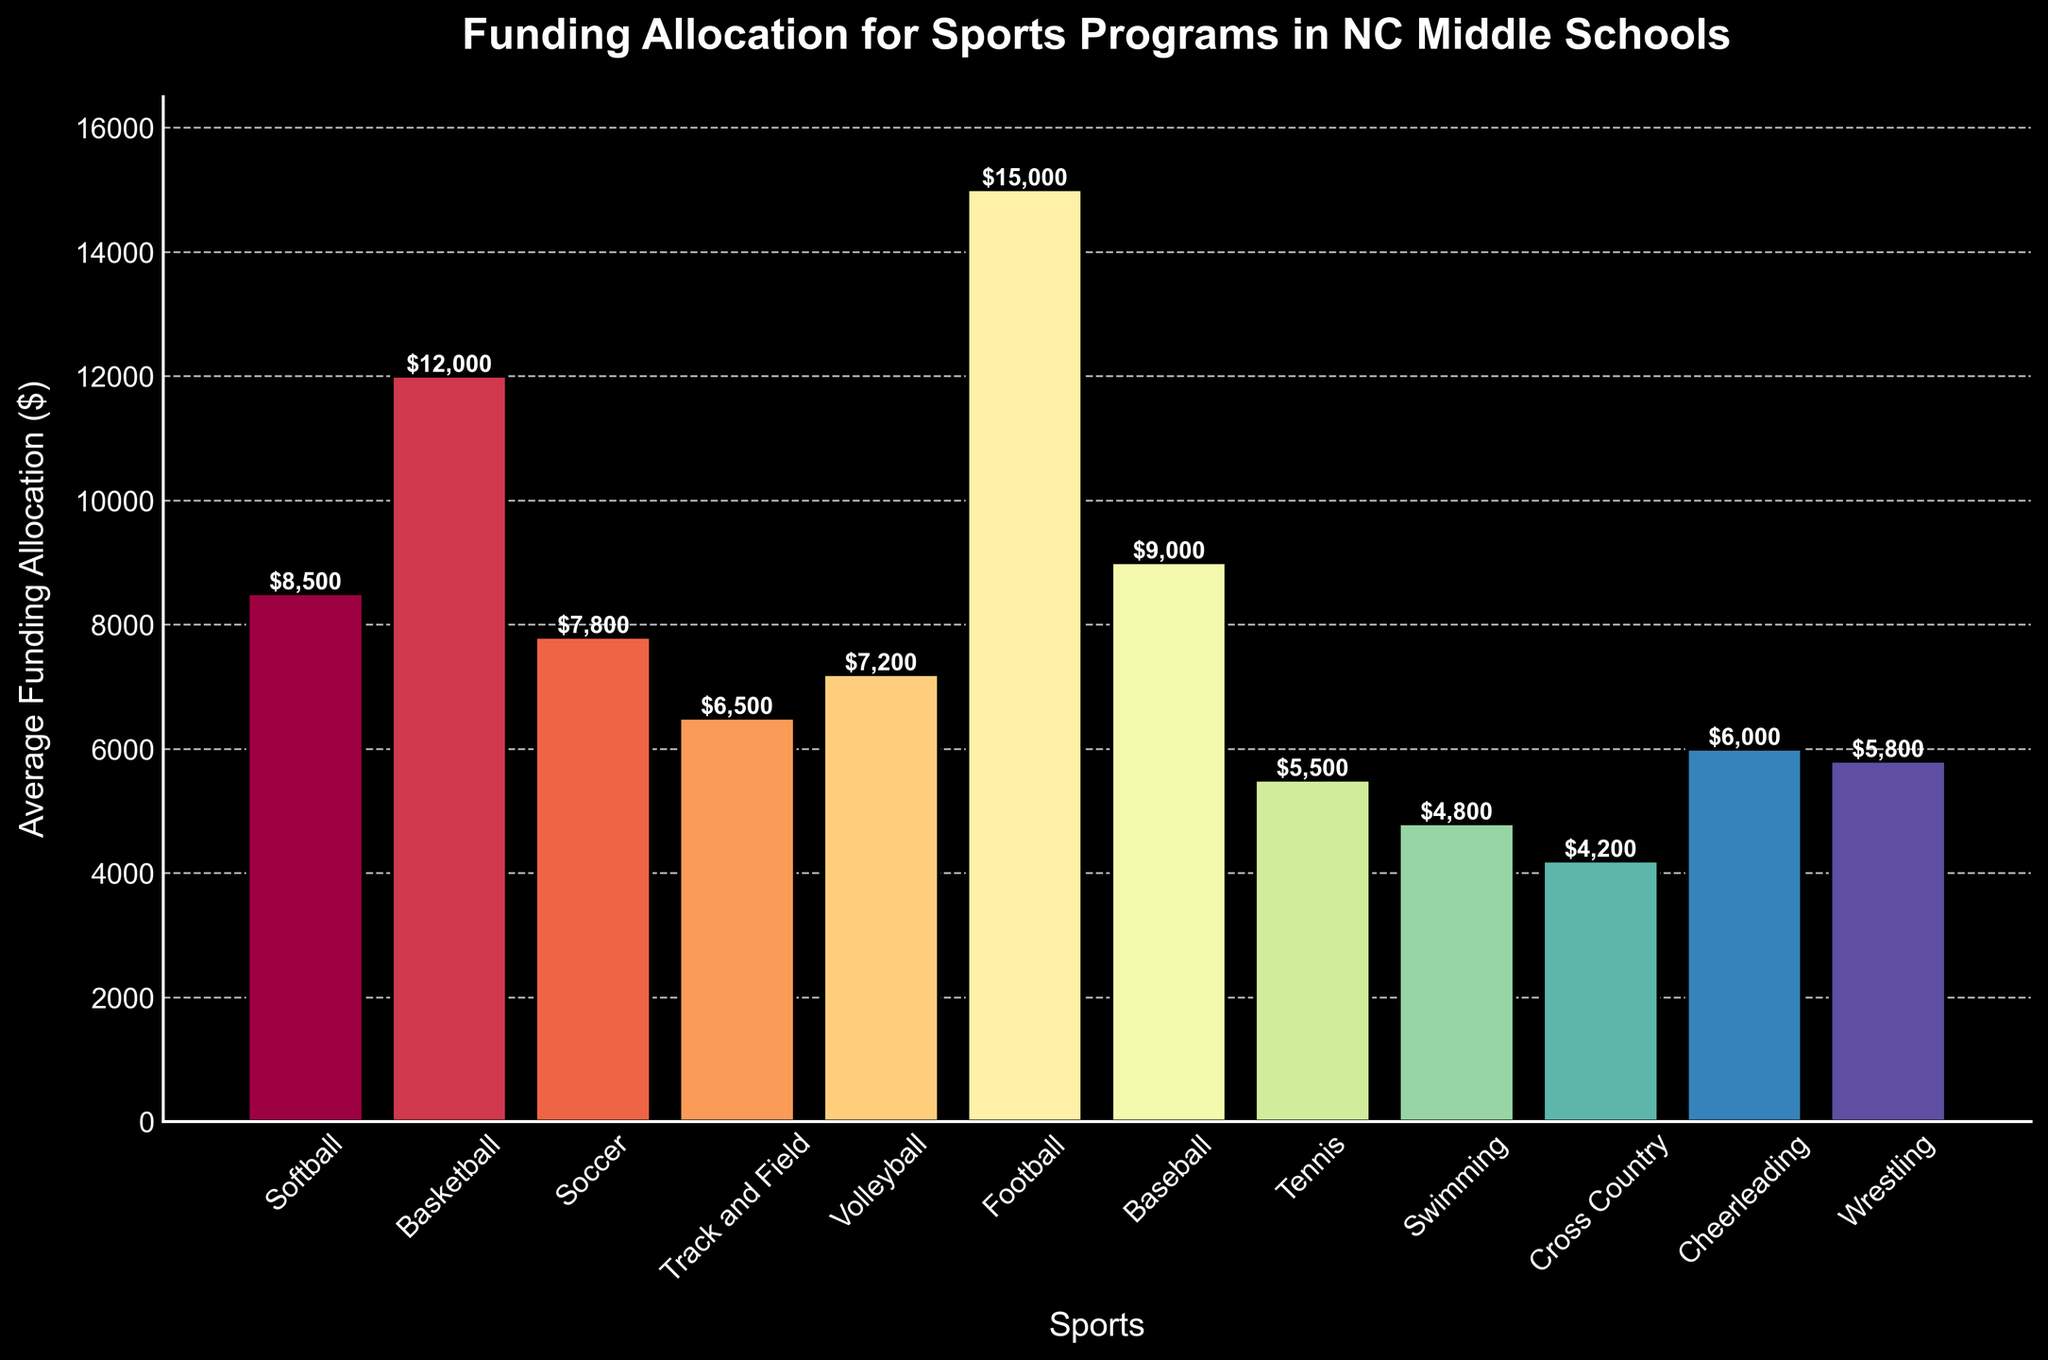Which sport has the highest average funding allocation? The bar representing Football is the tallest, indicating it has the highest funding.
Answer: Football Which two sports together receive less funding than Baseball? Baseball receives $9000. Cross Country ($4200) and Swimming ($4800) together receive $9000, equal to Baseball.
Answer: Cross Country and Swimming How much more funding does Football get compared to Soccer? Football receives $15000, and Soccer receives $7800. The difference is $15000 - $7800 = $7200.
Answer: $7200 What is the average funding allocation among the top three funded sports? The top three sports are Football ($15000), Basketball ($12000), and Baseball ($9000). The average is ($15000 + $12000 + $9000) / 3 = $12000.
Answer: $12000 Which sport has the lowest funding allocation and how much is it? The smallest bar represents Cross Country with an allocation of $4200.
Answer: Cross Country, $4200 Compare the total funding of Track and Field and Cheerleading against Basketball. Which is higher? Track and Field = $6500, Cheerleading = $6000, Total = $12500. Basketball = $12000. One is higher.
Answer: Track and Field and Cheerleading Which sports receive more funding than Volleyball? Volleyball receives $7200. Sports receiving more are Softball, Basketball, Football, Baseball.
Answer: Softball, Basketball, Football, Baseball What is the combined funding allocation for Soccer, Volleyball, and Wrestling? Soccer = $7800, Volleyball = $7200, Wrestling = $5800. Total is $7800 + $7200 + $5800 = $20800.
Answer: $20800 How does Basketball's funding compare to both Swimming and Tennis combined? Tennis = $5500, Swimming = $4800, combined = $10300. Basketball = $12000 is higher than $10300.
Answer: Basketball is higher What is the funding difference between the average of all sports and Track and Field? Sum all funding: $95000, number of sports: 12, average = $95000 / 12 ≈ $7917. Track and Field = $6500, difference = $7917 - $6500 = $1417.
Answer: $1417 